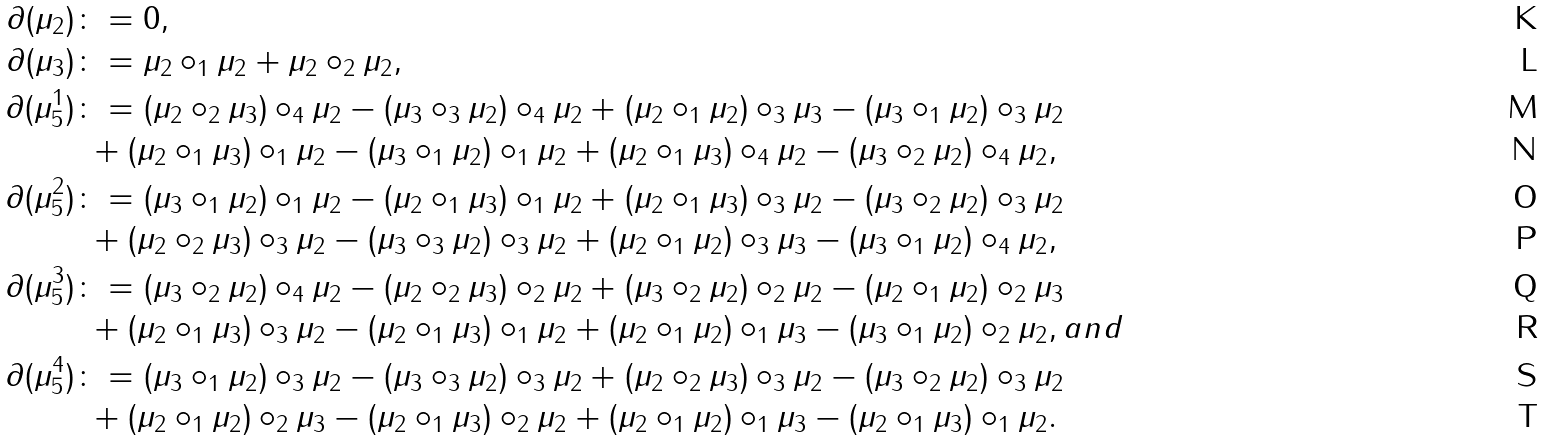<formula> <loc_0><loc_0><loc_500><loc_500>\partial ( \mu _ { 2 } ) & \colon = 0 , \\ \partial ( \mu _ { 3 } ) & \colon = \mu _ { 2 } \circ _ { 1 } \mu _ { 2 } + \mu _ { 2 } \circ _ { 2 } \mu _ { 2 } , \\ \partial ( \mu _ { 5 } ^ { 1 } ) & \colon = ( \mu _ { 2 } \circ _ { 2 } \mu _ { 3 } ) \circ _ { 4 } \mu _ { 2 } - ( \mu _ { 3 } \circ _ { 3 } \mu _ { 2 } ) \circ _ { 4 } \mu _ { 2 } + ( \mu _ { 2 } \circ _ { 1 } \mu _ { 2 } ) \circ _ { 3 } \mu _ { 3 } - ( \mu _ { 3 } \circ _ { 1 } \mu _ { 2 } ) \circ _ { 3 } \mu _ { 2 } \\ & \ + ( \mu _ { 2 } \circ _ { 1 } \mu _ { 3 } ) \circ _ { 1 } \mu _ { 2 } - ( \mu _ { 3 } \circ _ { 1 } \mu _ { 2 } ) \circ _ { 1 } \mu _ { 2 } + ( \mu _ { 2 } \circ _ { 1 } \mu _ { 3 } ) \circ _ { 4 } \mu _ { 2 } - ( \mu _ { 3 } \circ _ { 2 } \mu _ { 2 } ) \circ _ { 4 } \mu _ { 2 } , \\ \partial ( \mu _ { 5 } ^ { 2 } ) & \colon = ( \mu _ { 3 } \circ _ { 1 } \mu _ { 2 } ) \circ _ { 1 } \mu _ { 2 } - ( \mu _ { 2 } \circ _ { 1 } \mu _ { 3 } ) \circ _ { 1 } \mu _ { 2 } + ( \mu _ { 2 } \circ _ { 1 } \mu _ { 3 } ) \circ _ { 3 } \mu _ { 2 } - ( \mu _ { 3 } \circ _ { 2 } \mu _ { 2 } ) \circ _ { 3 } \mu _ { 2 } \\ & \ + ( \mu _ { 2 } \circ _ { 2 } \mu _ { 3 } ) \circ _ { 3 } \mu _ { 2 } - ( \mu _ { 3 } \circ _ { 3 } \mu _ { 2 } ) \circ _ { 3 } \mu _ { 2 } + ( \mu _ { 2 } \circ _ { 1 } \mu _ { 2 } ) \circ _ { 3 } \mu _ { 3 } - ( \mu _ { 3 } \circ _ { 1 } \mu _ { 2 } ) \circ _ { 4 } \mu _ { 2 } , \\ \partial ( \mu _ { 5 } ^ { 3 } ) & \colon = ( \mu _ { 3 } \circ _ { 2 } \mu _ { 2 } ) \circ _ { 4 } \mu _ { 2 } - ( \mu _ { 2 } \circ _ { 2 } \mu _ { 3 } ) \circ _ { 2 } \mu _ { 2 } + ( \mu _ { 3 } \circ _ { 2 } \mu _ { 2 } ) \circ _ { 2 } \mu _ { 2 } - ( \mu _ { 2 } \circ _ { 1 } \mu _ { 2 } ) \circ _ { 2 } \mu _ { 3 } \\ & \ + ( \mu _ { 2 } \circ _ { 1 } \mu _ { 3 } ) \circ _ { 3 } \mu _ { 2 } - ( \mu _ { 2 } \circ _ { 1 } \mu _ { 3 } ) \circ _ { 1 } \mu _ { 2 } + ( \mu _ { 2 } \circ _ { 1 } \mu _ { 2 } ) \circ _ { 1 } \mu _ { 3 } - ( \mu _ { 3 } \circ _ { 1 } \mu _ { 2 } ) \circ _ { 2 } \mu _ { 2 } , a n d \\ \partial ( \mu _ { 5 } ^ { 4 } ) & \colon = ( \mu _ { 3 } \circ _ { 1 } \mu _ { 2 } ) \circ _ { 3 } \mu _ { 2 } - ( \mu _ { 3 } \circ _ { 3 } \mu _ { 2 } ) \circ _ { 3 } \mu _ { 2 } + ( \mu _ { 2 } \circ _ { 2 } \mu _ { 3 } ) \circ _ { 3 } \mu _ { 2 } - ( \mu _ { 3 } \circ _ { 2 } \mu _ { 2 } ) \circ _ { 3 } \mu _ { 2 } \\ & \ + ( \mu _ { 2 } \circ _ { 1 } \mu _ { 2 } ) \circ _ { 2 } \mu _ { 3 } - ( \mu _ { 2 } \circ _ { 1 } \mu _ { 3 } ) \circ _ { 2 } \mu _ { 2 } + ( \mu _ { 2 } \circ _ { 1 } \mu _ { 2 } ) \circ _ { 1 } \mu _ { 3 } - ( \mu _ { 2 } \circ _ { 1 } \mu _ { 3 } ) \circ _ { 1 } \mu _ { 2 } .</formula> 